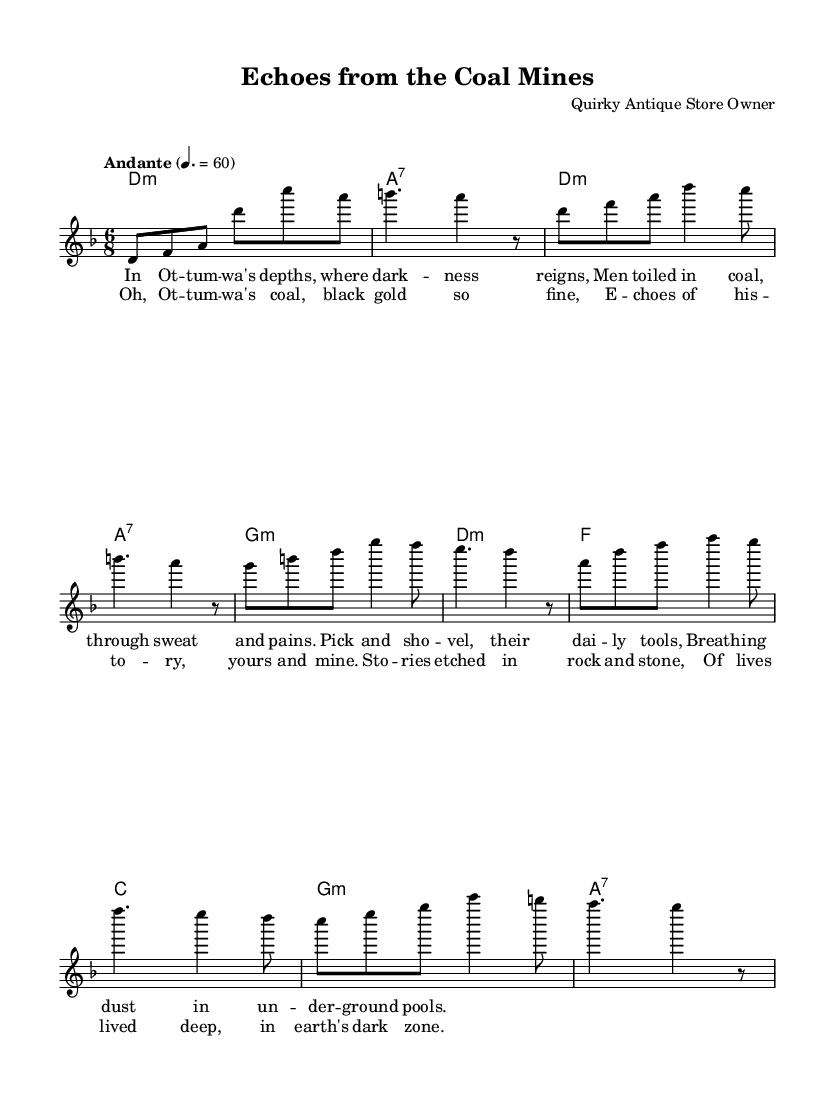What is the key signature of this music? The key signature is D minor, indicated by one flat (Bb) and gives the tonal center for the piece.
Answer: D minor What is the time signature of this music? The time signature is 6/8, which is indicated at the beginning of the music, suggesting a compound duple meter.
Answer: 6/8 What is the tempo marking for this piece? The tempo marking is "Andante", which suggests a moderately slow pace. It is noted along with a specific metronome marking of 60 beats per minute.
Answer: Andante What type of musical form is utilized in this sheet music? The musical form consists of verses and a chorus, alternating between thematic elements that enhance storytelling.
Answer: Verse-Chorus What is the mood conveyed in the lyrics? The lyrics describe the hard life endured by coal miners, which evokes a somber and reflective mood.
Answer: Somber How many measures are in the chorus of the song? The chorus consists of four measures, clearly marked and structured in the musical notation presented.
Answer: Four What narrative theme is explored in the lyrics? The lyrics explore the theme of coal mining history in Ottumwa, focusing on the struggles and experiences of miners.
Answer: Coal mining history 